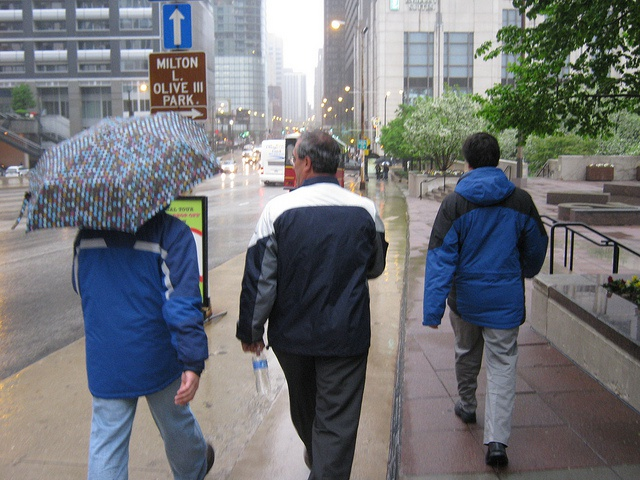Describe the objects in this image and their specific colors. I can see people in gray, black, and white tones, people in gray, navy, blue, and darkblue tones, people in gray, navy, black, and blue tones, umbrella in gray and darkgray tones, and bus in gray, white, and darkgray tones in this image. 